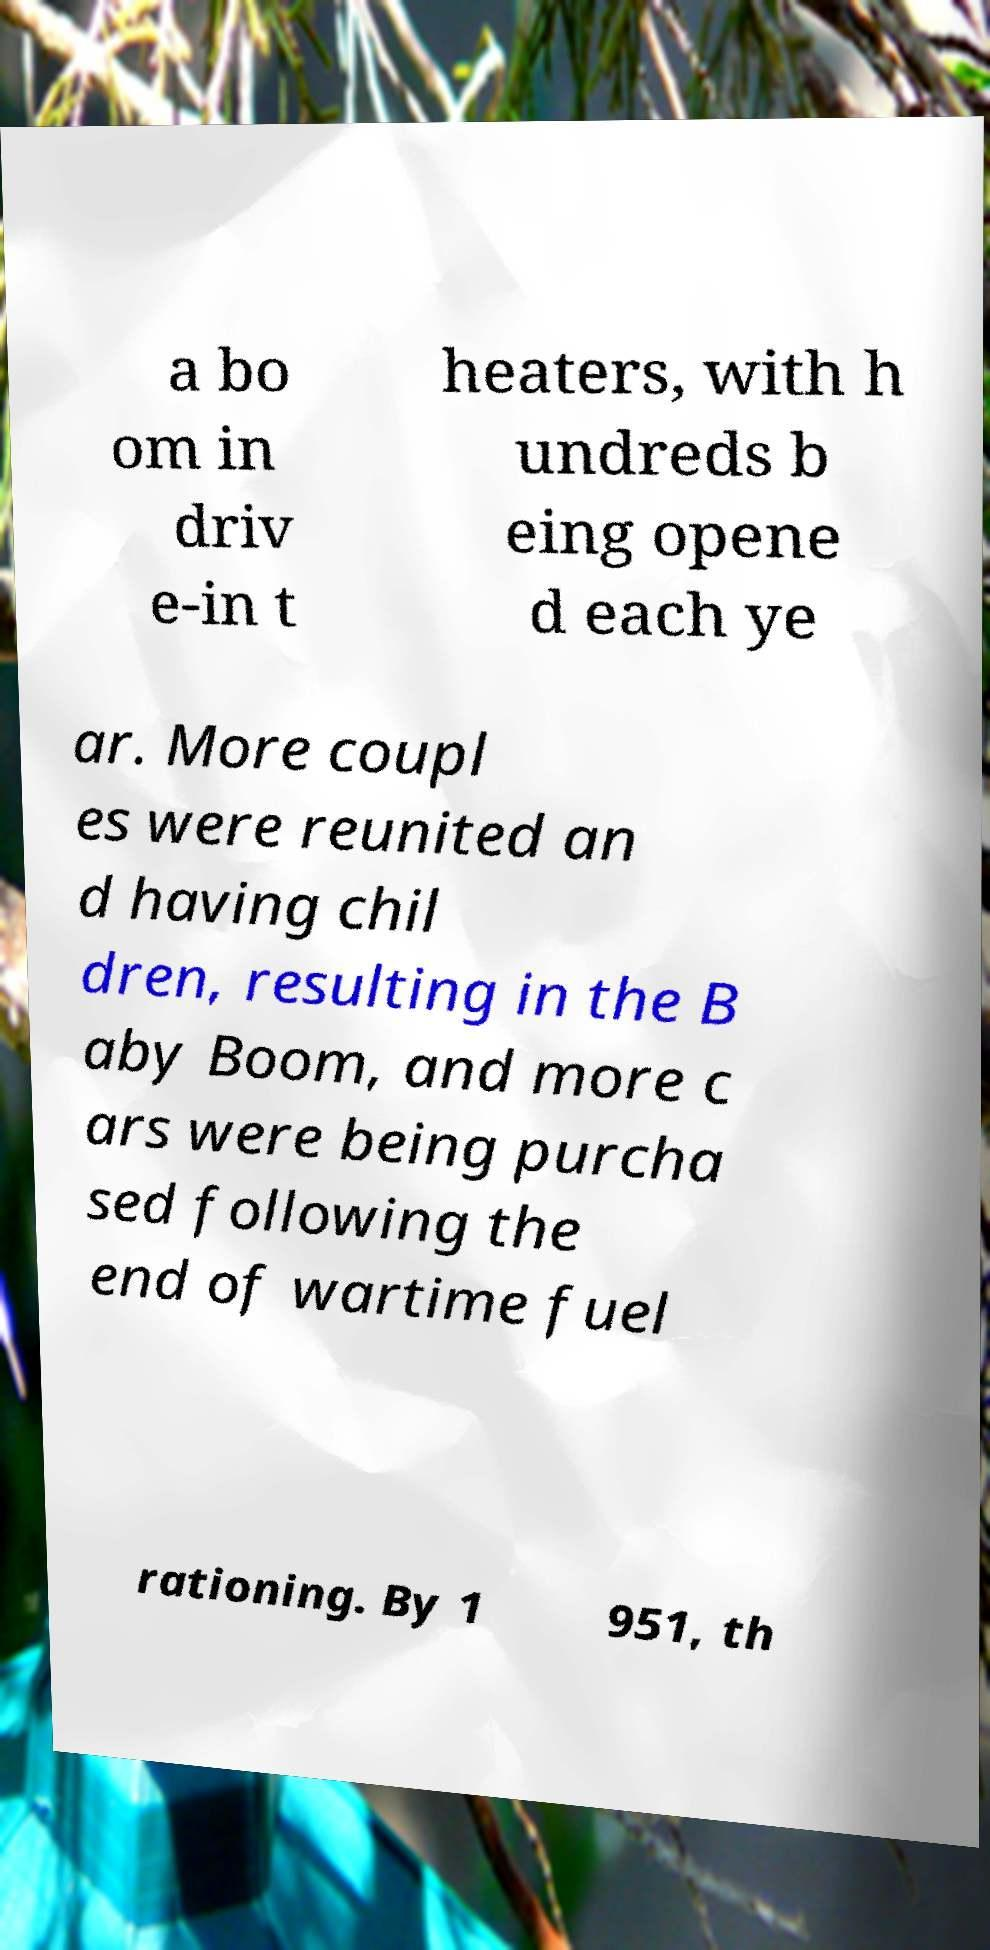Please read and relay the text visible in this image. What does it say? a bo om in driv e-in t heaters, with h undreds b eing opene d each ye ar. More coupl es were reunited an d having chil dren, resulting in the B aby Boom, and more c ars were being purcha sed following the end of wartime fuel rationing. By 1 951, th 